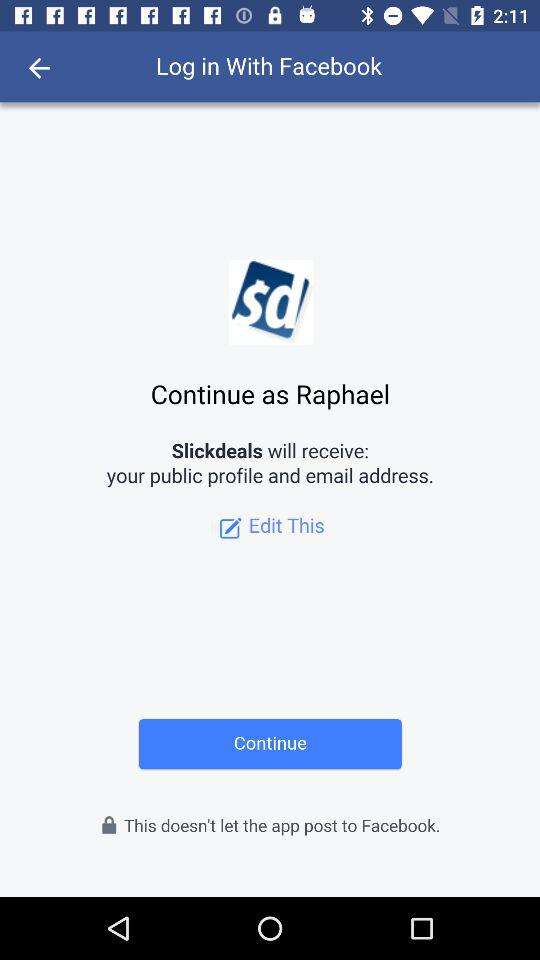What is the login name? The login name is "Raphael". 